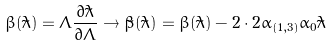<formula> <loc_0><loc_0><loc_500><loc_500>\beta ( \tilde { \lambda } ) = \Lambda \frac { \partial \tilde { \lambda } } { \partial \Lambda } \rightarrow \tilde { \beta } ( \tilde { \lambda } ) = \beta ( \tilde { \lambda } ) - 2 \cdot 2 \alpha _ { ( 1 , 3 ) } \alpha _ { 0 } \tilde { \lambda }</formula> 